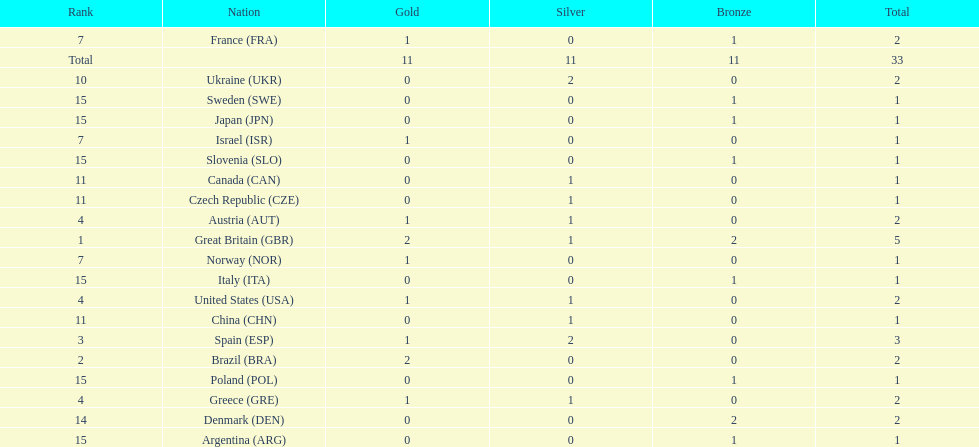Which nation was the only one to receive 3 medals? Spain (ESP). 